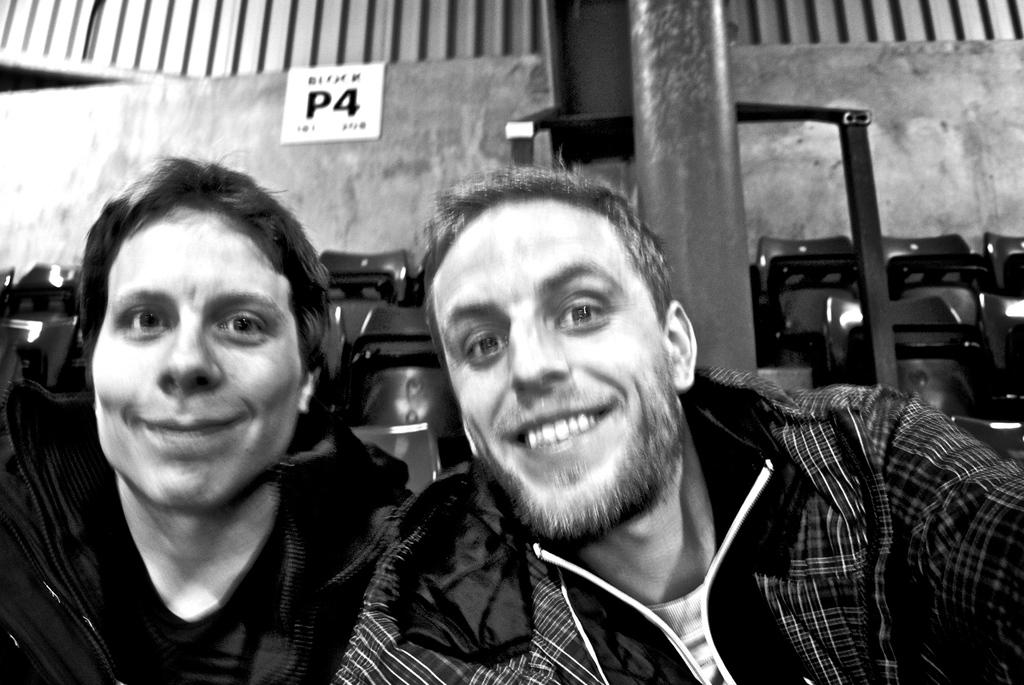How many people are in the image? There are two persons in the image. What can be seen in the background of the image? There are seats in the background of the image. What is located in the middle of the image? There is a pole in the middle of the image. What is on the wall in the image? There is a poster on the wall in the image. What are the two persons wearing? Both persons are wearing jackets. What type of knife is being used by the grandmother in the image? There is no grandmother or knife present in the image. What kind of paste is being applied to the poster in the image? There is no paste being applied to the poster in the image; it is simply a poster on the wall. 